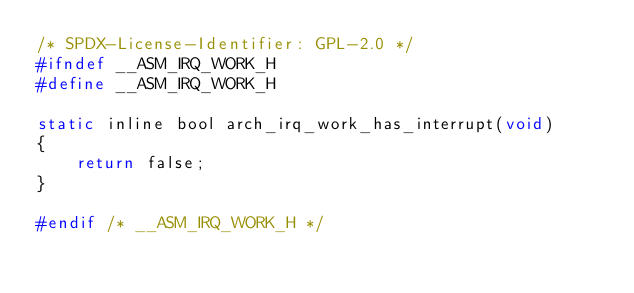Convert code to text. <code><loc_0><loc_0><loc_500><loc_500><_C_>/* SPDX-License-Identifier: GPL-2.0 */
#ifndef __ASM_IRQ_WORK_H
#define __ASM_IRQ_WORK_H

static inline bool arch_irq_work_has_interrupt(void)
{
	return false;
}

#endif /* __ASM_IRQ_WORK_H */

</code> 